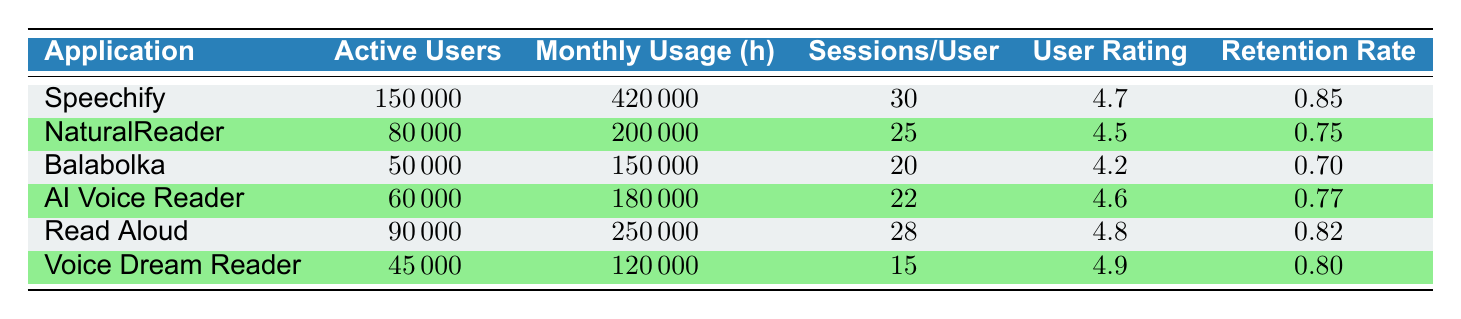What is the application with the highest number of active users? Looking at the table, Speechify has 150,000 active users, which is the highest compared to the other applications listed.
Answer: Speechify What is the monthly usage hours for Read Aloud? The table shows that Read Aloud has 250,000 monthly usage hours listed under its usage metric.
Answer: 250,000 What is the average user feedback rating across all applications? Adding the user feedback ratings: (4.7 + 4.5 + 4.2 + 4.6 + 4.8 + 4.9) = 27.7, and dividing by the number of applications (6), gives an average rating of 27.7 / 6 = 4.62.
Answer: 4.62 Which application has the lowest retention rate? Looking at the retention rates, Balabolka has a retention rate of 0.70, which is lower than the others in the list.
Answer: Balabolka What is the difference in active users between Speechify and NaturalReader? Speechify has 150,000 active users, and NaturalReader has 80,000. The difference is 150,000 - 80,000 = 70,000.
Answer: 70,000 How many total active users are there across all applications combined? Summing the active users: (150,000 + 80,000 + 50,000 + 60,000 + 90,000 + 45,000) = 475,000.
Answer: 475,000 Is the retention rate for Voice Dream Reader greater than for AI Voice Reader? Voice Dream Reader has a retention rate of 0.80, while AI Voice Reader has a rate of 0.77. Since 0.80 is greater than 0.77, the statement is true.
Answer: Yes Which application has the highest sessions per user? The table shows that Speechify has the highest sessions per user with a value of 30 sessions.
Answer: Speechify What is the average retention rate of applications with more than 70,000 active users? The applications with more than 70,000 active users are Speechify (0.85), NaturalReader (0.75), and Read Aloud (0.82). The sum is 0.85 + 0.75 + 0.82 = 2.42 and dividing by 3 gives an average of 2.42 / 3 = 0.81.
Answer: 0.81 What is the maximum monthly usage hours among the applications listed? By examining the monthly usage hours, Speechify has the highest at 420,000 hours, which is more than the others.
Answer: 420,000 